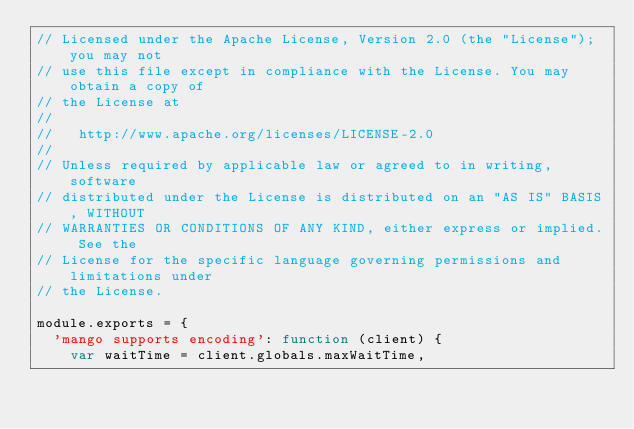<code> <loc_0><loc_0><loc_500><loc_500><_JavaScript_>// Licensed under the Apache License, Version 2.0 (the "License"); you may not
// use this file except in compliance with the License. You may obtain a copy of
// the License at
//
//   http://www.apache.org/licenses/LICENSE-2.0
//
// Unless required by applicable law or agreed to in writing, software
// distributed under the License is distributed on an "AS IS" BASIS, WITHOUT
// WARRANTIES OR CONDITIONS OF ANY KIND, either express or implied. See the
// License for the specific language governing permissions and limitations under
// the License.

module.exports = {
  'mango supports encoding': function (client) {
    var waitTime = client.globals.maxWaitTime,</code> 